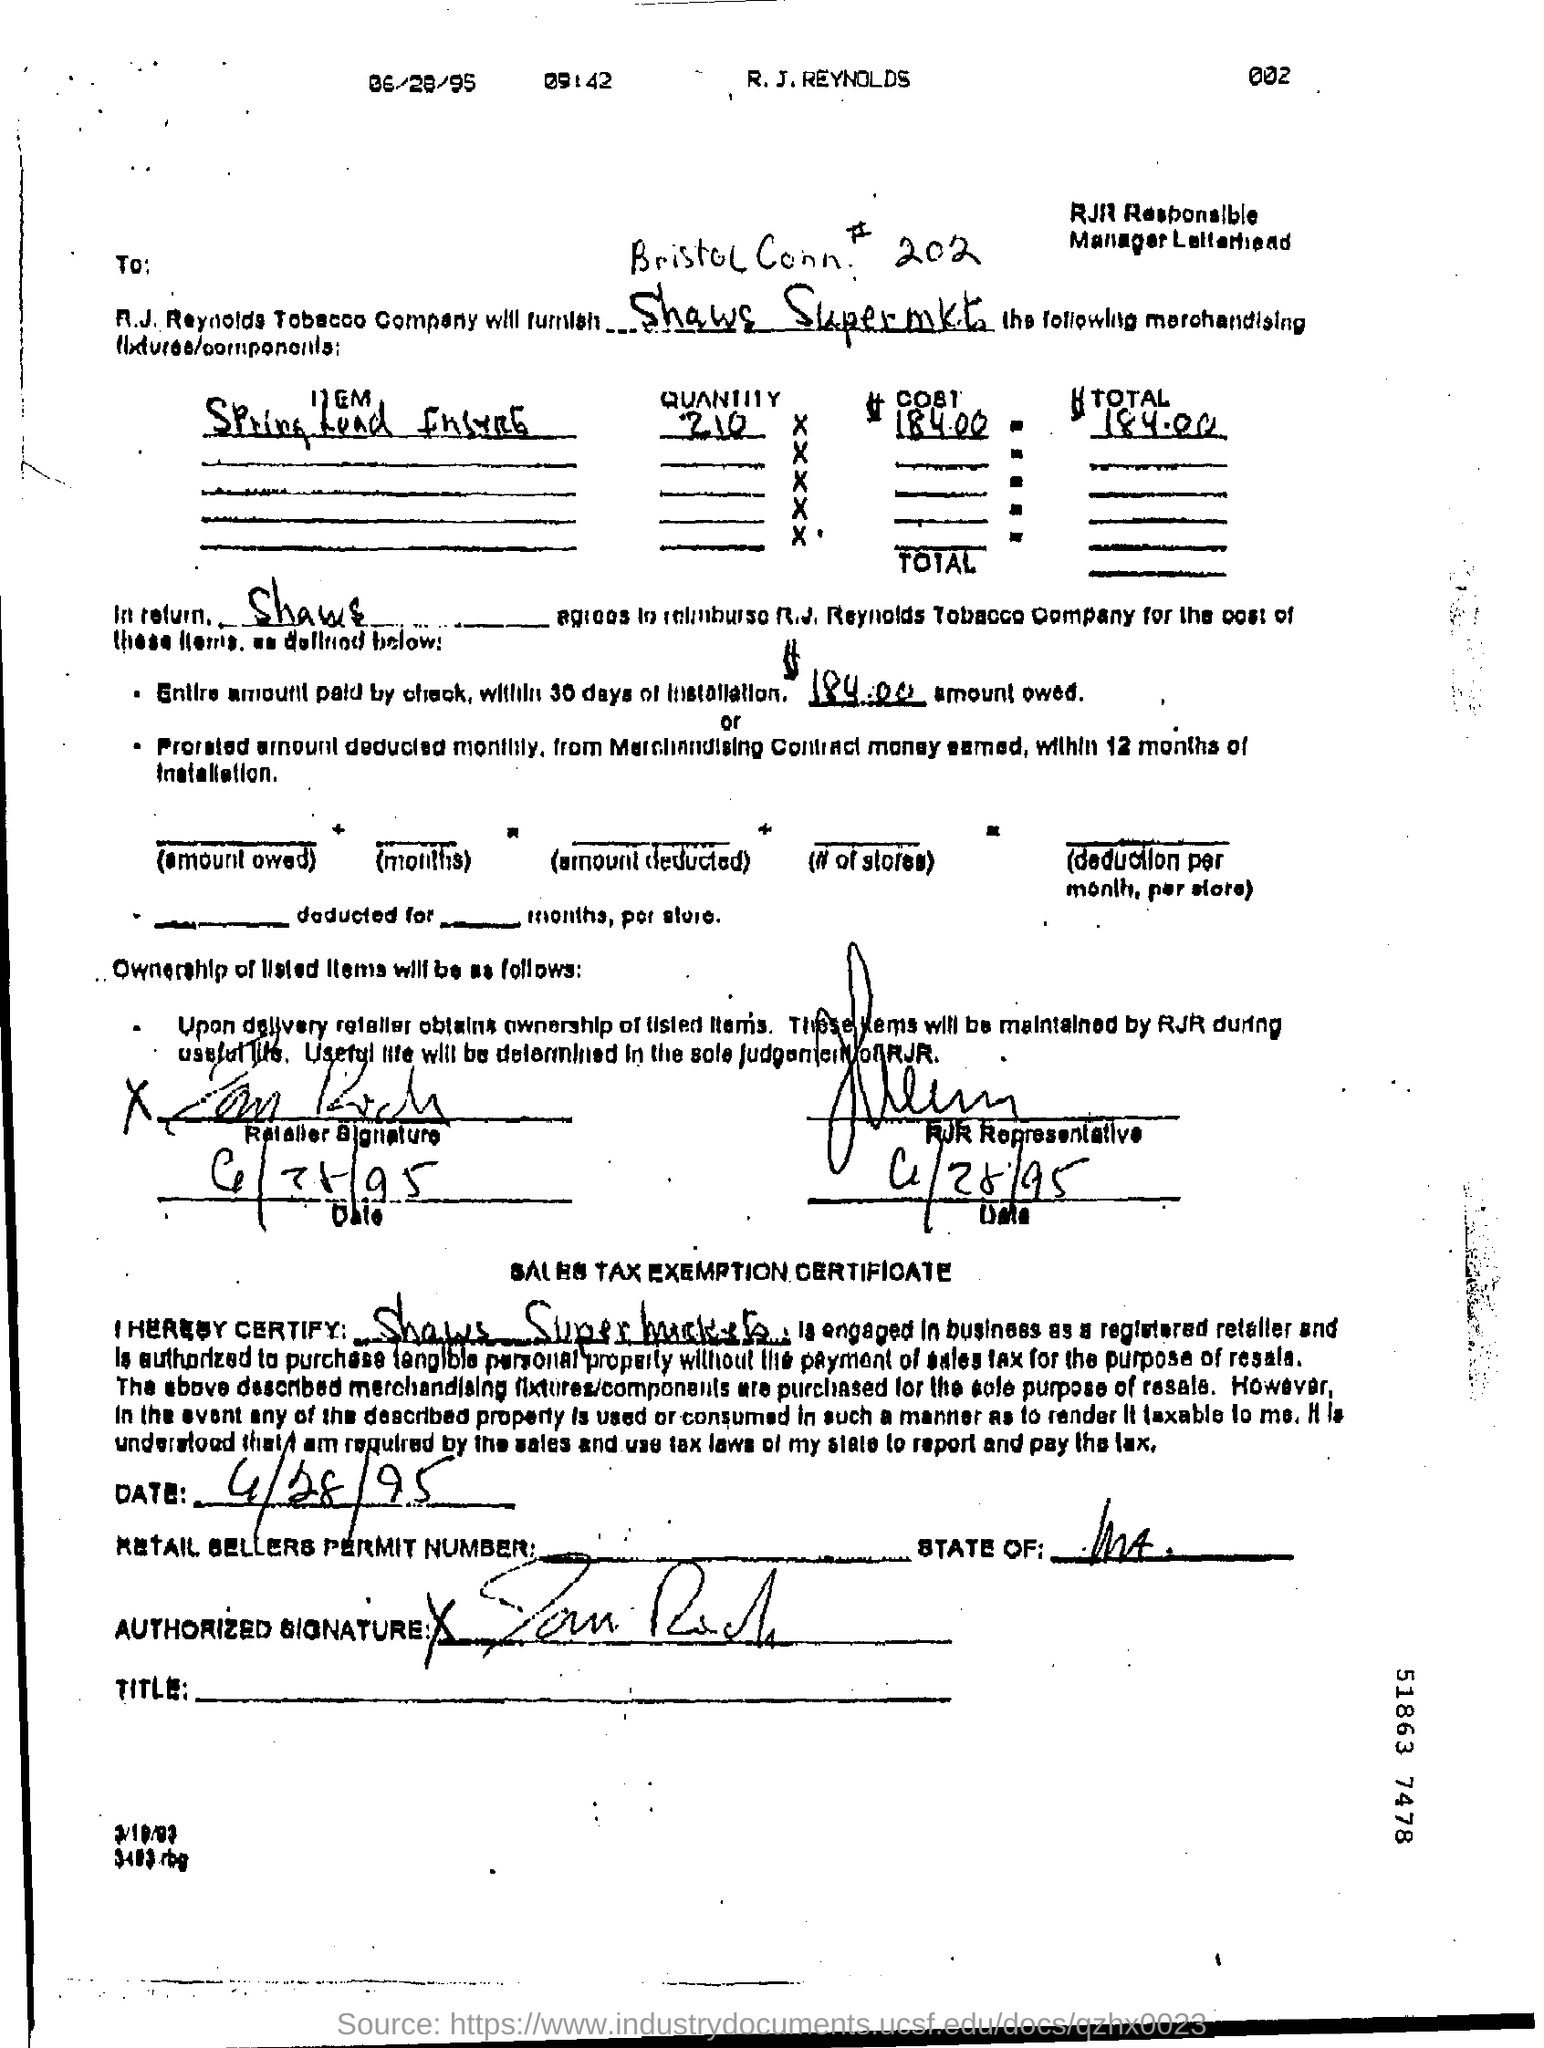Draw attention to some important aspects in this diagram. The total amount is 184.00. 